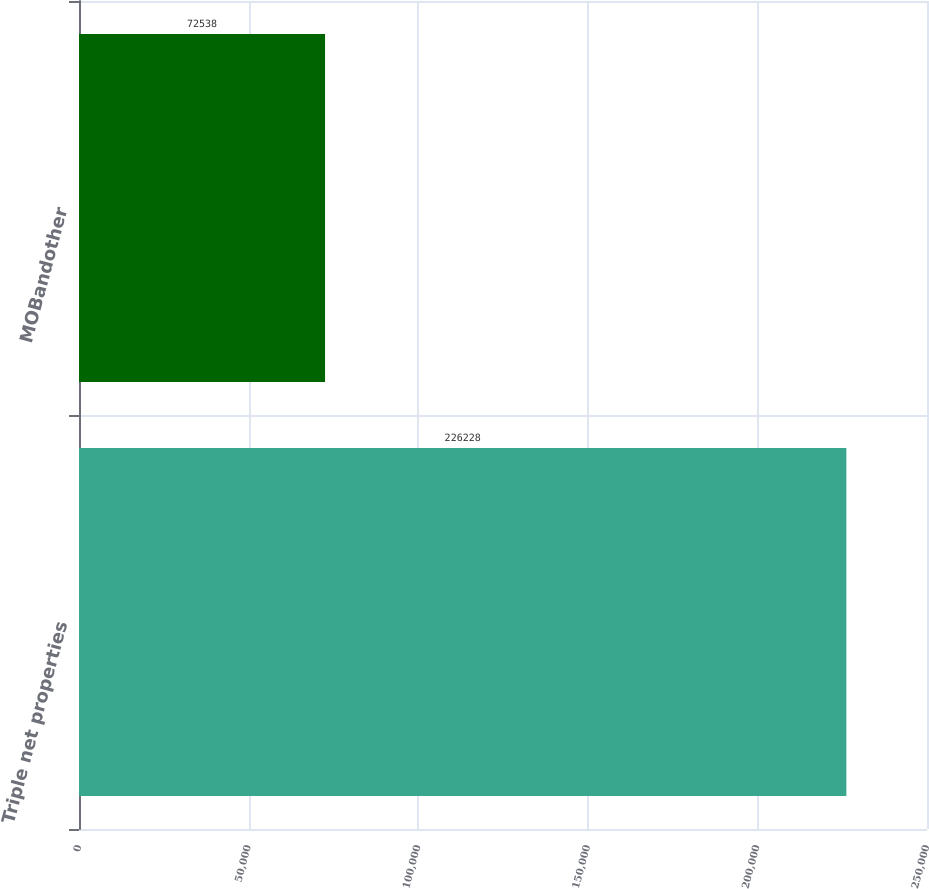<chart> <loc_0><loc_0><loc_500><loc_500><bar_chart><fcel>Triple net properties<fcel>MOBandother<nl><fcel>226228<fcel>72538<nl></chart> 